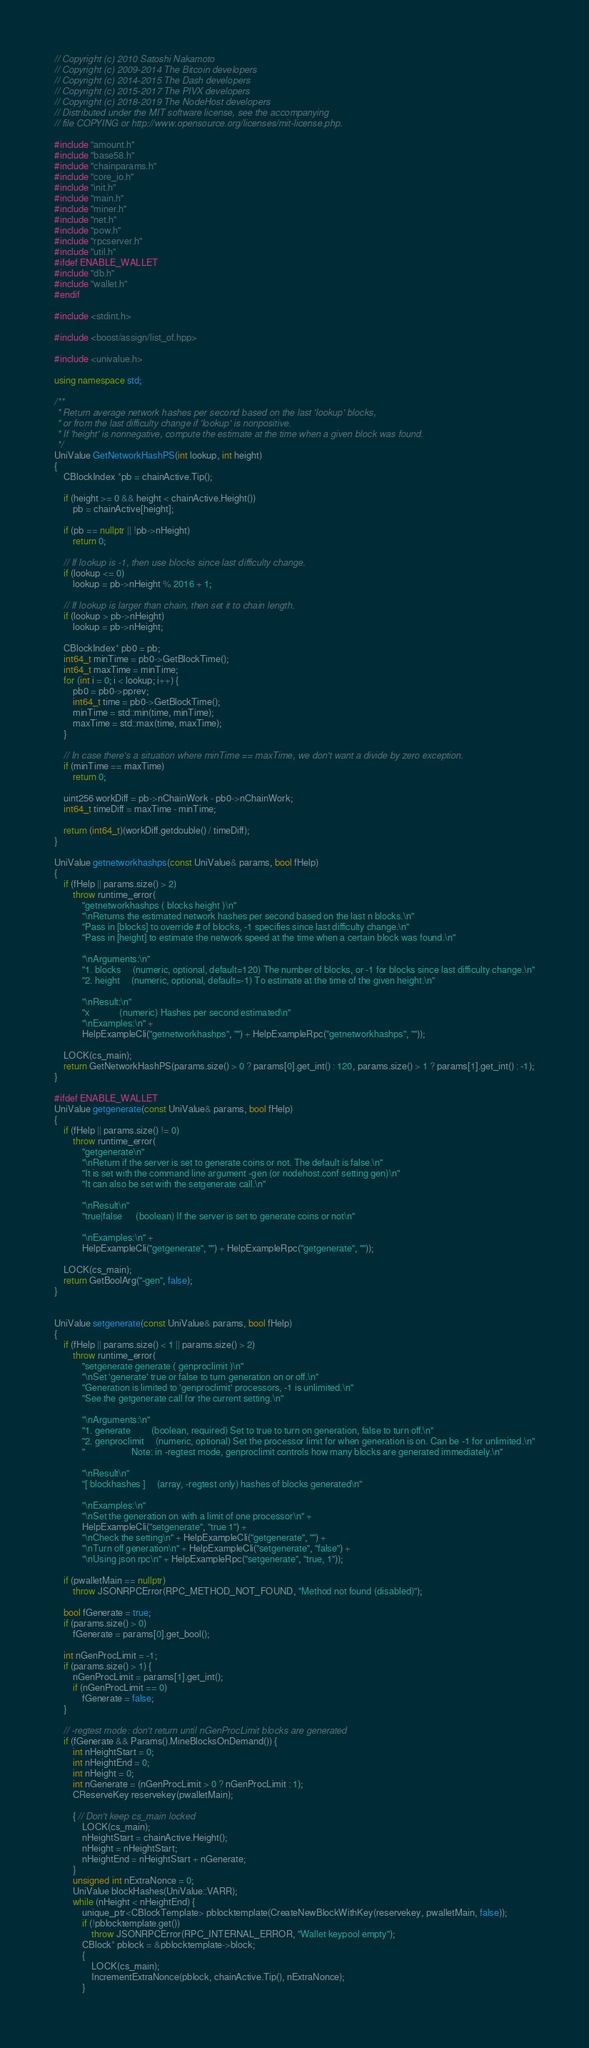Convert code to text. <code><loc_0><loc_0><loc_500><loc_500><_C++_>// Copyright (c) 2010 Satoshi Nakamoto
// Copyright (c) 2009-2014 The Bitcoin developers
// Copyright (c) 2014-2015 The Dash developers
// Copyright (c) 2015-2017 The PIVX developers
// Copyright (c) 2018-2019 The NodeHost developers
// Distributed under the MIT software license, see the accompanying
// file COPYING or http://www.opensource.org/licenses/mit-license.php.

#include "amount.h"
#include "base58.h"
#include "chainparams.h"
#include "core_io.h"
#include "init.h"
#include "main.h"
#include "miner.h"
#include "net.h"
#include "pow.h"
#include "rpcserver.h"
#include "util.h"
#ifdef ENABLE_WALLET
#include "db.h"
#include "wallet.h"
#endif

#include <stdint.h>

#include <boost/assign/list_of.hpp>

#include <univalue.h>

using namespace std;

/**
 * Return average network hashes per second based on the last 'lookup' blocks,
 * or from the last difficulty change if 'lookup' is nonpositive.
 * If 'height' is nonnegative, compute the estimate at the time when a given block was found.
 */
UniValue GetNetworkHashPS(int lookup, int height)
{
    CBlockIndex *pb = chainActive.Tip();

    if (height >= 0 && height < chainActive.Height())
        pb = chainActive[height];

    if (pb == nullptr || !pb->nHeight)
        return 0;

    // If lookup is -1, then use blocks since last difficulty change.
    if (lookup <= 0)
        lookup = pb->nHeight % 2016 + 1;

    // If lookup is larger than chain, then set it to chain length.
    if (lookup > pb->nHeight)
        lookup = pb->nHeight;

    CBlockIndex* pb0 = pb;
    int64_t minTime = pb0->GetBlockTime();
    int64_t maxTime = minTime;
    for (int i = 0; i < lookup; i++) {
        pb0 = pb0->pprev;
        int64_t time = pb0->GetBlockTime();
        minTime = std::min(time, minTime);
        maxTime = std::max(time, maxTime);
    }

    // In case there's a situation where minTime == maxTime, we don't want a divide by zero exception.
    if (minTime == maxTime)
        return 0;

    uint256 workDiff = pb->nChainWork - pb0->nChainWork;
    int64_t timeDiff = maxTime - minTime;

    return (int64_t)(workDiff.getdouble() / timeDiff);
}

UniValue getnetworkhashps(const UniValue& params, bool fHelp)
{
    if (fHelp || params.size() > 2)
        throw runtime_error(
            "getnetworkhashps ( blocks height )\n"
            "\nReturns the estimated network hashes per second based on the last n blocks.\n"
            "Pass in [blocks] to override # of blocks, -1 specifies since last difficulty change.\n"
            "Pass in [height] to estimate the network speed at the time when a certain block was found.\n"

            "\nArguments:\n"
            "1. blocks     (numeric, optional, default=120) The number of blocks, or -1 for blocks since last difficulty change.\n"
            "2. height     (numeric, optional, default=-1) To estimate at the time of the given height.\n"

            "\nResult:\n"
            "x             (numeric) Hashes per second estimated\n"
            "\nExamples:\n" +
            HelpExampleCli("getnetworkhashps", "") + HelpExampleRpc("getnetworkhashps", ""));

    LOCK(cs_main);
    return GetNetworkHashPS(params.size() > 0 ? params[0].get_int() : 120, params.size() > 1 ? params[1].get_int() : -1);
}

#ifdef ENABLE_WALLET
UniValue getgenerate(const UniValue& params, bool fHelp)
{
    if (fHelp || params.size() != 0)
        throw runtime_error(
            "getgenerate\n"
            "\nReturn if the server is set to generate coins or not. The default is false.\n"
            "It is set with the command line argument -gen (or nodehost.conf setting gen)\n"
            "It can also be set with the setgenerate call.\n"

            "\nResult\n"
            "true|false      (boolean) If the server is set to generate coins or not\n"

            "\nExamples:\n" +
            HelpExampleCli("getgenerate", "") + HelpExampleRpc("getgenerate", ""));

    LOCK(cs_main);
    return GetBoolArg("-gen", false);
}


UniValue setgenerate(const UniValue& params, bool fHelp)
{
    if (fHelp || params.size() < 1 || params.size() > 2)
        throw runtime_error(
            "setgenerate generate ( genproclimit )\n"
            "\nSet 'generate' true or false to turn generation on or off.\n"
            "Generation is limited to 'genproclimit' processors, -1 is unlimited.\n"
            "See the getgenerate call for the current setting.\n"

            "\nArguments:\n"
            "1. generate         (boolean, required) Set to true to turn on generation, false to turn off.\n"
            "2. genproclimit     (numeric, optional) Set the processor limit for when generation is on. Can be -1 for unlimited.\n"
            "                    Note: in -regtest mode, genproclimit controls how many blocks are generated immediately.\n"

            "\nResult\n"
            "[ blockhashes ]     (array, -regtest only) hashes of blocks generated\n"

            "\nExamples:\n"
            "\nSet the generation on with a limit of one processor\n" +
            HelpExampleCli("setgenerate", "true 1") +
            "\nCheck the setting\n" + HelpExampleCli("getgenerate", "") +
            "\nTurn off generation\n" + HelpExampleCli("setgenerate", "false") +
            "\nUsing json rpc\n" + HelpExampleRpc("setgenerate", "true, 1"));

    if (pwalletMain == nullptr)
        throw JSONRPCError(RPC_METHOD_NOT_FOUND, "Method not found (disabled)");

    bool fGenerate = true;
    if (params.size() > 0)
        fGenerate = params[0].get_bool();

    int nGenProcLimit = -1;
    if (params.size() > 1) {
        nGenProcLimit = params[1].get_int();
        if (nGenProcLimit == 0)
            fGenerate = false;
    }

    // -regtest mode: don't return until nGenProcLimit blocks are generated
    if (fGenerate && Params().MineBlocksOnDemand()) {
        int nHeightStart = 0;
        int nHeightEnd = 0;
        int nHeight = 0;
        int nGenerate = (nGenProcLimit > 0 ? nGenProcLimit : 1);
        CReserveKey reservekey(pwalletMain);

        { // Don't keep cs_main locked
            LOCK(cs_main);
            nHeightStart = chainActive.Height();
            nHeight = nHeightStart;
            nHeightEnd = nHeightStart + nGenerate;
        }
        unsigned int nExtraNonce = 0;
        UniValue blockHashes(UniValue::VARR);
        while (nHeight < nHeightEnd) {
            unique_ptr<CBlockTemplate> pblocktemplate(CreateNewBlockWithKey(reservekey, pwalletMain, false));
            if (!pblocktemplate.get())
                throw JSONRPCError(RPC_INTERNAL_ERROR, "Wallet keypool empty");
            CBlock* pblock = &pblocktemplate->block;
            {
                LOCK(cs_main);
                IncrementExtraNonce(pblock, chainActive.Tip(), nExtraNonce);
            }</code> 